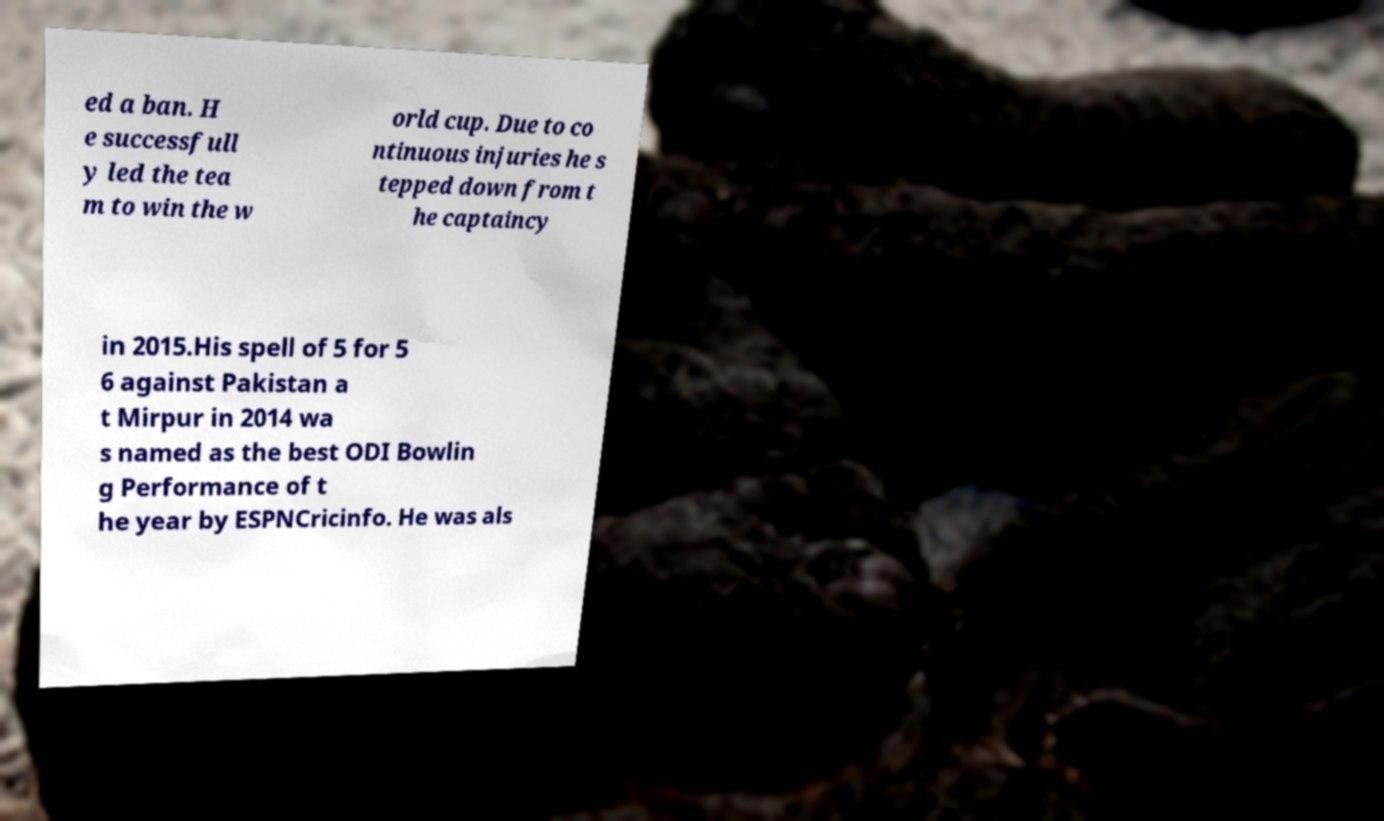For documentation purposes, I need the text within this image transcribed. Could you provide that? ed a ban. H e successfull y led the tea m to win the w orld cup. Due to co ntinuous injuries he s tepped down from t he captaincy in 2015.His spell of 5 for 5 6 against Pakistan a t Mirpur in 2014 wa s named as the best ODI Bowlin g Performance of t he year by ESPNCricinfo. He was als 